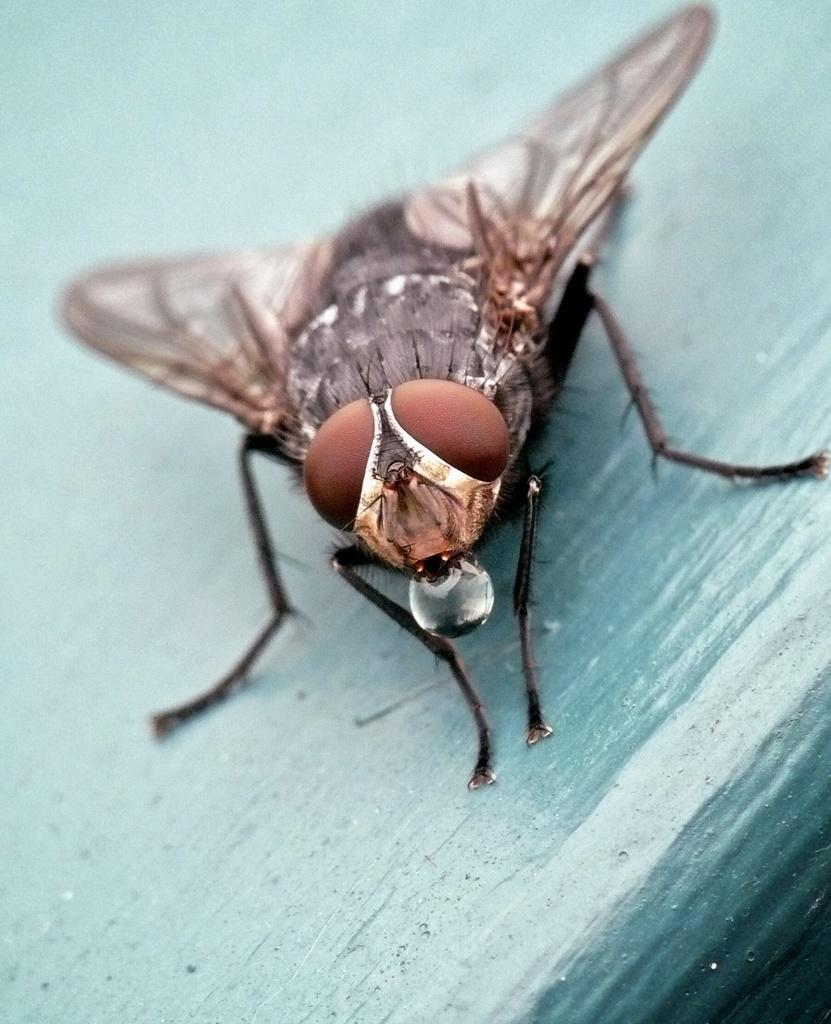What is present in the image? There is a fly in the image. Where is the fly located? The fly is on a wooden plank. What type of food is the fly eating in the image? There is no food visible in the image, and the fly is not shown eating anything. 